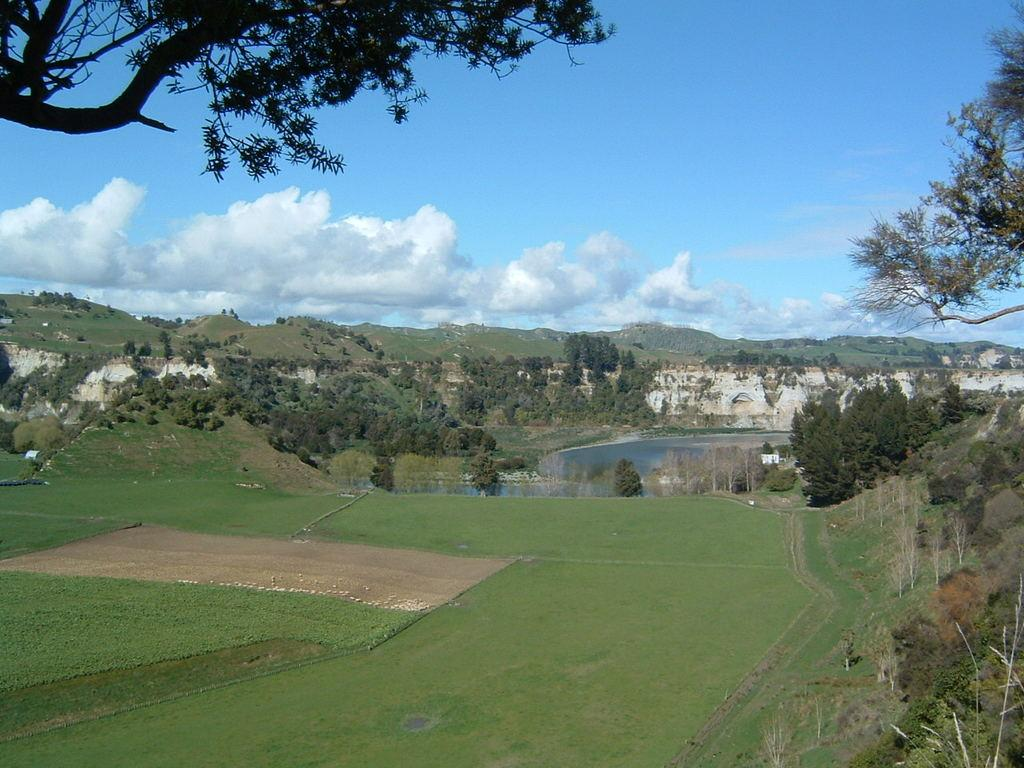What type of vegetation can be seen in the image? There is grass in the image. What other natural elements are present in the image? There are trees in the image. What is the main feature at the center of the image? There is water at the center of the image. What is the taste of the water in the image? The taste of the water cannot be determined from the image, as taste is not a visual characteristic. 